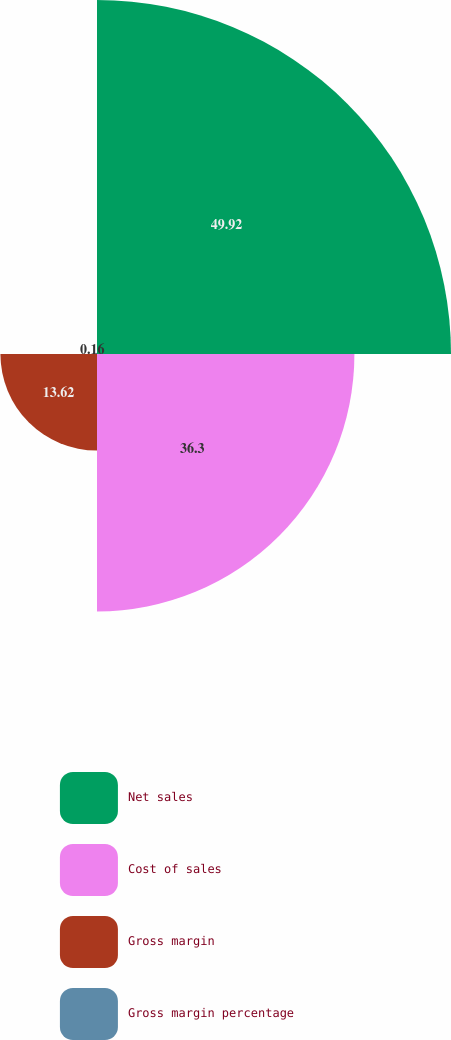Convert chart to OTSL. <chart><loc_0><loc_0><loc_500><loc_500><pie_chart><fcel>Net sales<fcel>Cost of sales<fcel>Gross margin<fcel>Gross margin percentage<nl><fcel>49.92%<fcel>36.3%<fcel>13.62%<fcel>0.16%<nl></chart> 